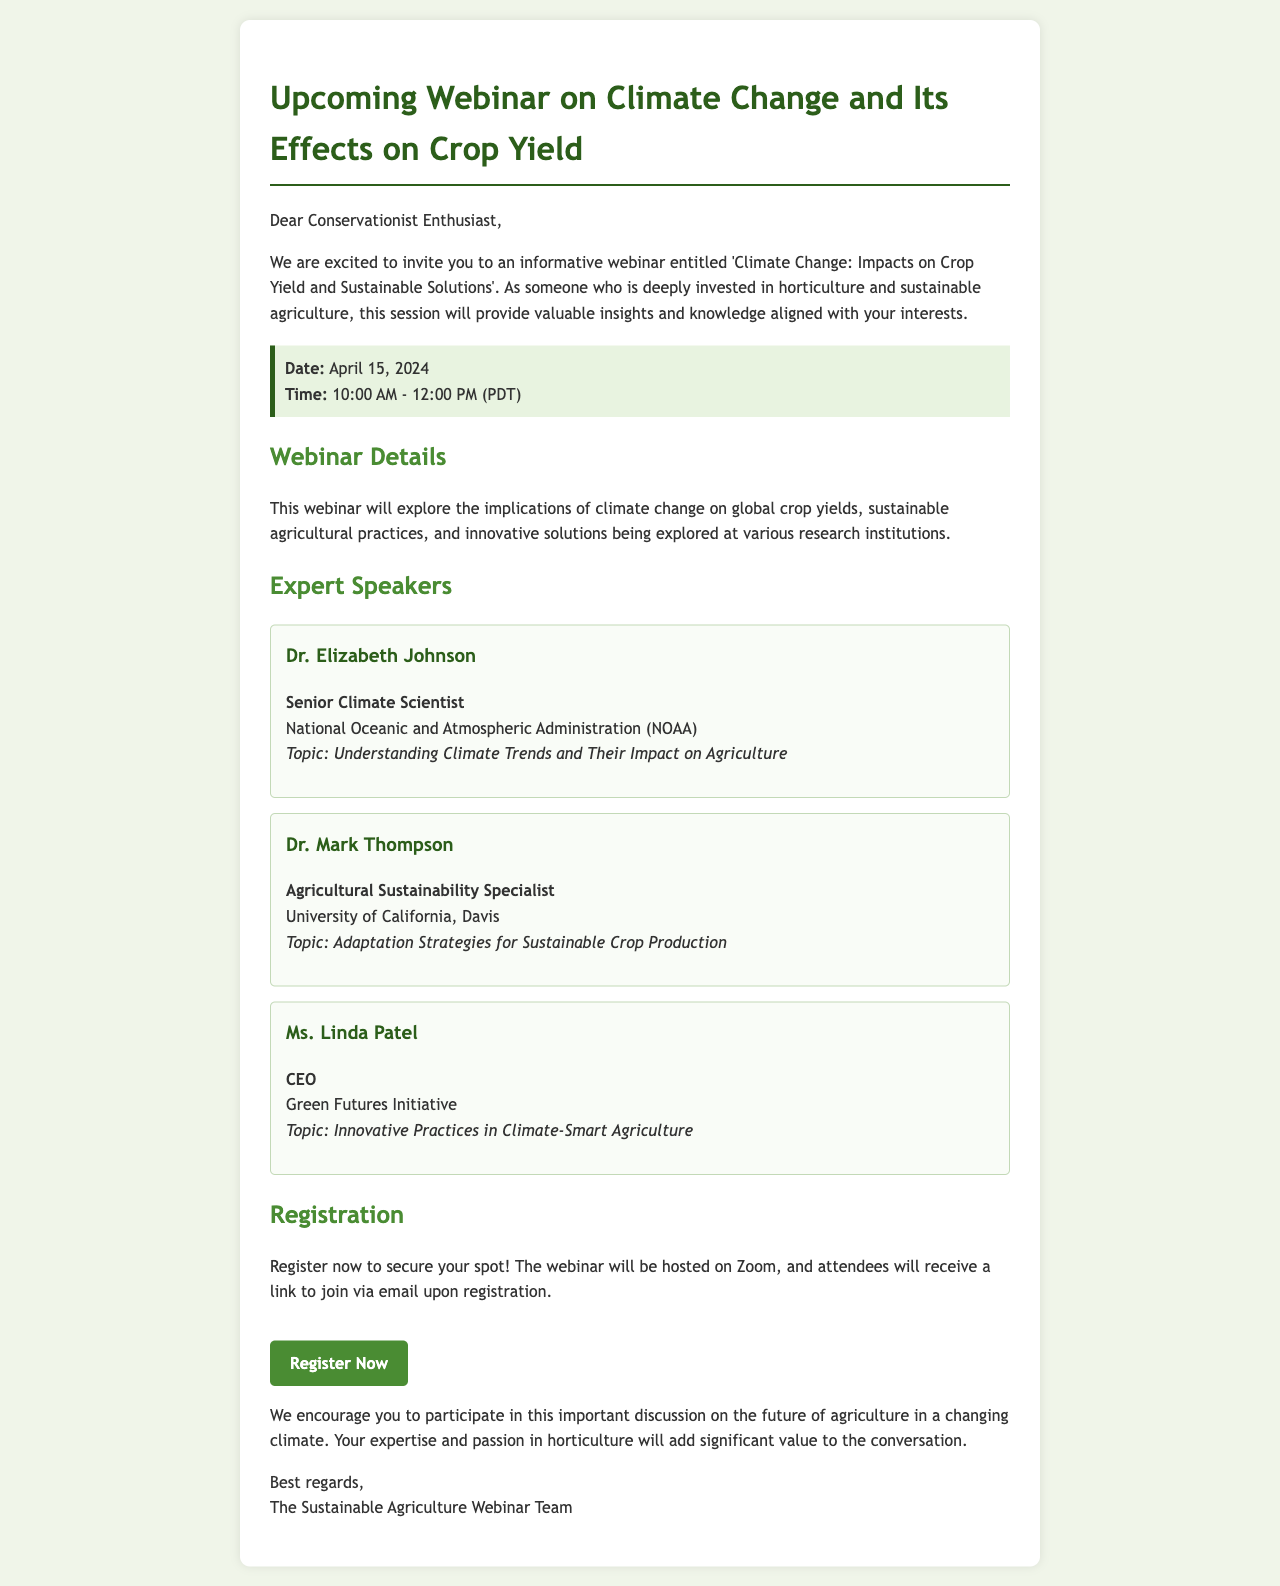What is the title of the webinar? The title is stated at the beginning of the email as 'Climate Change: Impacts on Crop Yield and Sustainable Solutions'.
Answer: Climate Change: Impacts on Crop Yield and Sustainable Solutions Who is the first expert speaker listed? The first expert speaker mentioned is Dr. Elizabeth Johnson.
Answer: Dr. Elizabeth Johnson What date will the webinar be held? The date is clearly provided in the document as April 15, 2024.
Answer: April 15, 2024 What is the registration link for the webinar? The registration link is provided prominently in the email as 'https://www.climatewebinar.org/register'.
Answer: https://www.climatewebinar.org/register What topic will Dr. Mark Thompson discuss? The topic for Dr. Mark Thompson is indicated in his description as 'Adaptation Strategies for Sustainable Crop Production'.
Answer: Adaptation Strategies for Sustainable Crop Production What time will the webinar start? The start time of the webinar is stated in the date-time section as 10:00 AM (PDT).
Answer: 10:00 AM Why might participants be encouraged to attend? Participants are encouraged to contribute to an important discussion on agriculture's future in a changing climate, given their expertise and passion in horticulture.
Answer: Important discussion on agriculture's future What will attendees receive after registering? Attendees will receive a link to join via email upon registration.
Answer: A link to join via email 